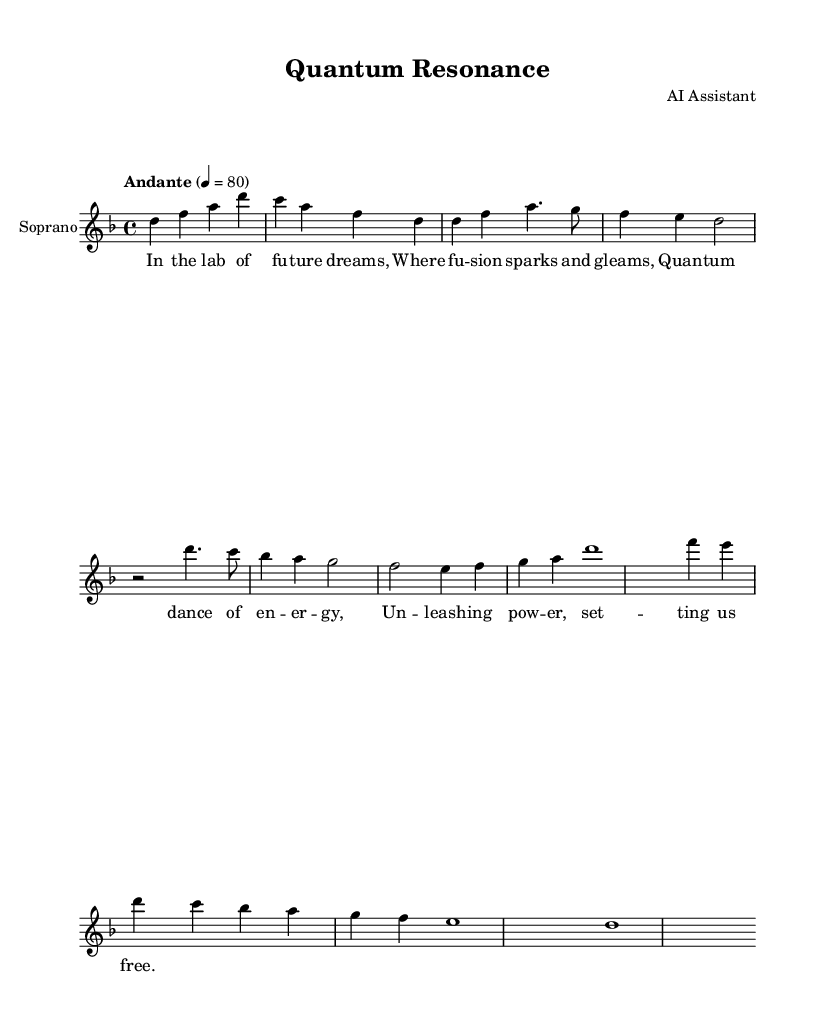What is the key signature of this music? The key signature is indicated at the beginning of the staff and shows two flats, which denotes B flat major or G minor (the relative), but in this case, it’s specified to be D minor.
Answer: D minor What is the time signature of the piece? The time signature is located at the start of the music and is written as 4/4, meaning there are four beats in each measure and a quarter note receives one beat.
Answer: 4/4 What is the tempo marking of the music? The tempo marking is found at the beginning, stating "Andante" with a metronome marking of quarter note equals 80, indicating a moderately slow tempo.
Answer: Andante What is the dynamic range indicated in the score? The score does not explicitly indicate any dynamic markings, hence it relies on performing expressions typical for operatic singing that may include dynamics such as crescendos or decrescendos.
Answer: None Which section marks the transition between the Chorus and the Bridge? The Chorus is followed by a distinct pattern leading to the Bridge starting after the last measure of the Chorus, looking for the measures, it is clear that the transition is at the end of the last line of the Chorus section.
Answer: End of the Chorus What thematic element is introduced in the verse lyrics? The verse lyrics discuss a futuristic laboratory with fusion and quantum energy themes, which ties the music to the overall sci-fi element of the opera, giving it a narrative arc about liberation and power through energy.
Answer: Futuristic energy themes What is the duration of the first measure? The first measure consists of four notes: d, f, a, and d, all of which are quarter notes, adding up to a total duration of one whole measure of four beats.
Answer: Four beats 